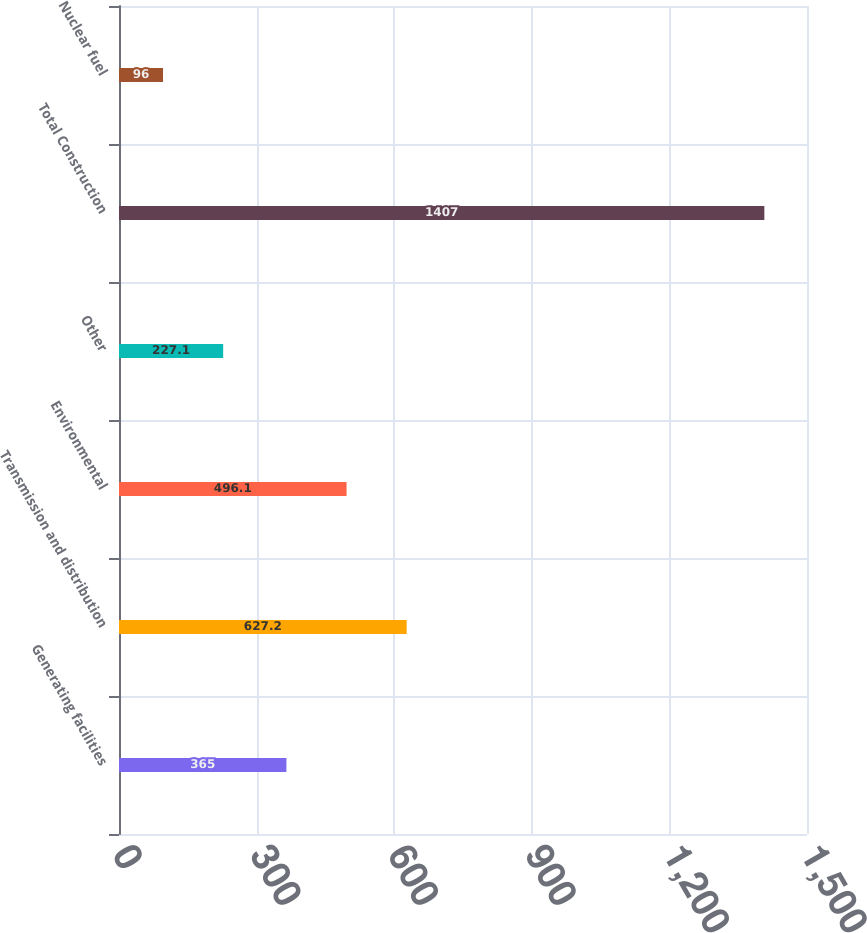Convert chart. <chart><loc_0><loc_0><loc_500><loc_500><bar_chart><fcel>Generating facilities<fcel>Transmission and distribution<fcel>Environmental<fcel>Other<fcel>Total Construction<fcel>Nuclear fuel<nl><fcel>365<fcel>627.2<fcel>496.1<fcel>227.1<fcel>1407<fcel>96<nl></chart> 